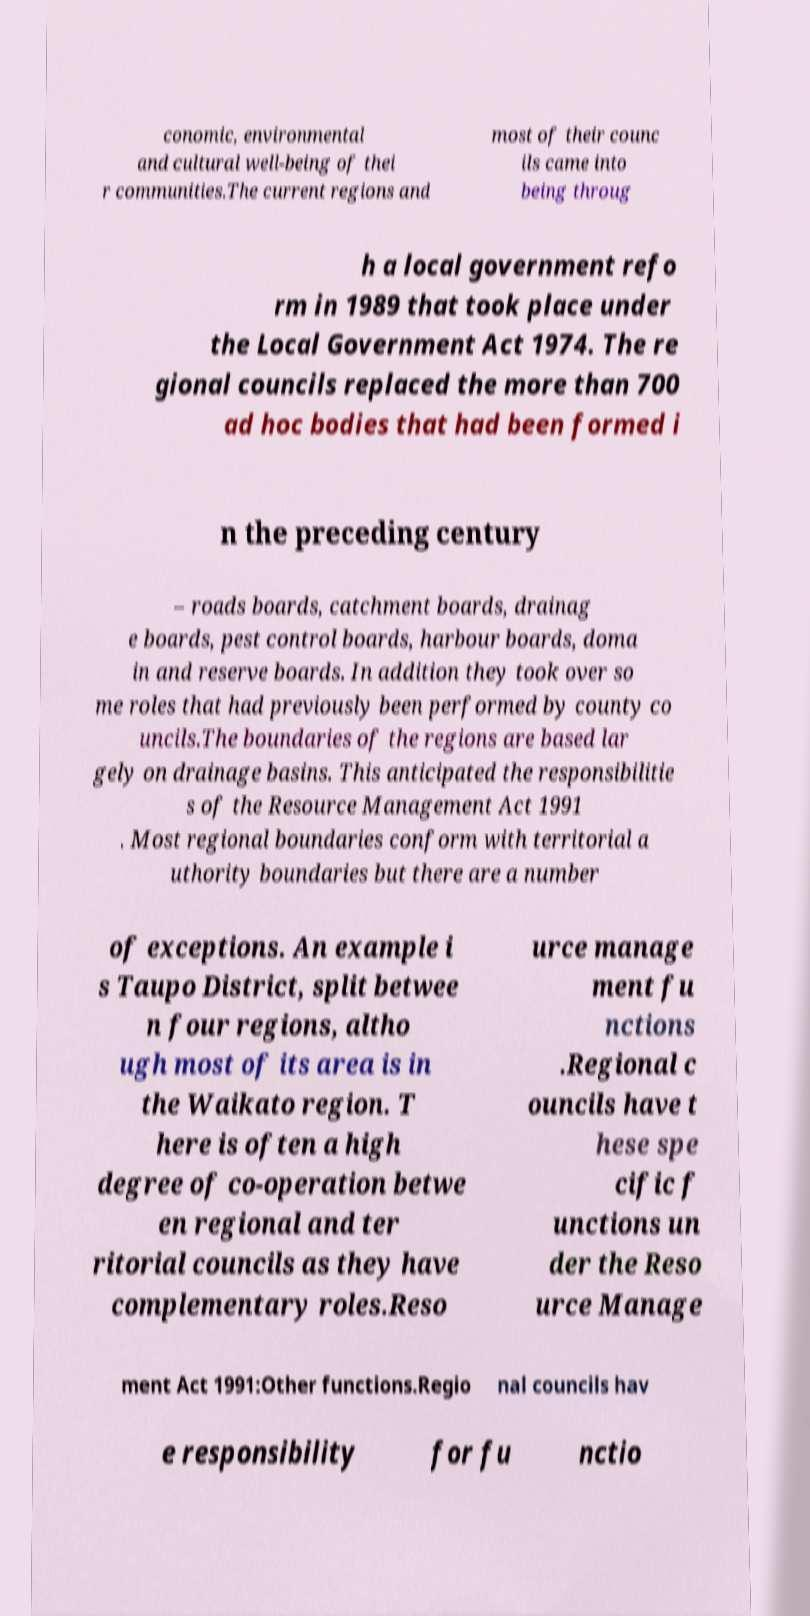For documentation purposes, I need the text within this image transcribed. Could you provide that? conomic, environmental and cultural well-being of thei r communities.The current regions and most of their counc ils came into being throug h a local government refo rm in 1989 that took place under the Local Government Act 1974. The re gional councils replaced the more than 700 ad hoc bodies that had been formed i n the preceding century – roads boards, catchment boards, drainag e boards, pest control boards, harbour boards, doma in and reserve boards. In addition they took over so me roles that had previously been performed by county co uncils.The boundaries of the regions are based lar gely on drainage basins. This anticipated the responsibilitie s of the Resource Management Act 1991 . Most regional boundaries conform with territorial a uthority boundaries but there are a number of exceptions. An example i s Taupo District, split betwee n four regions, altho ugh most of its area is in the Waikato region. T here is often a high degree of co-operation betwe en regional and ter ritorial councils as they have complementary roles.Reso urce manage ment fu nctions .Regional c ouncils have t hese spe cific f unctions un der the Reso urce Manage ment Act 1991:Other functions.Regio nal councils hav e responsibility for fu nctio 